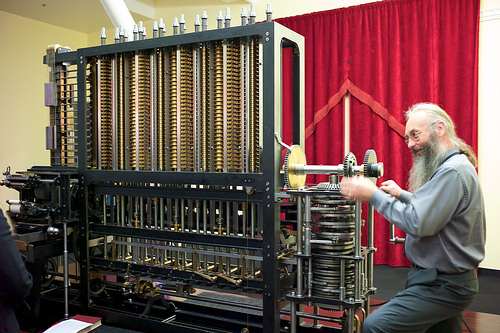<image>
Is the man to the right of the machine? Yes. From this viewpoint, the man is positioned to the right side relative to the machine. 